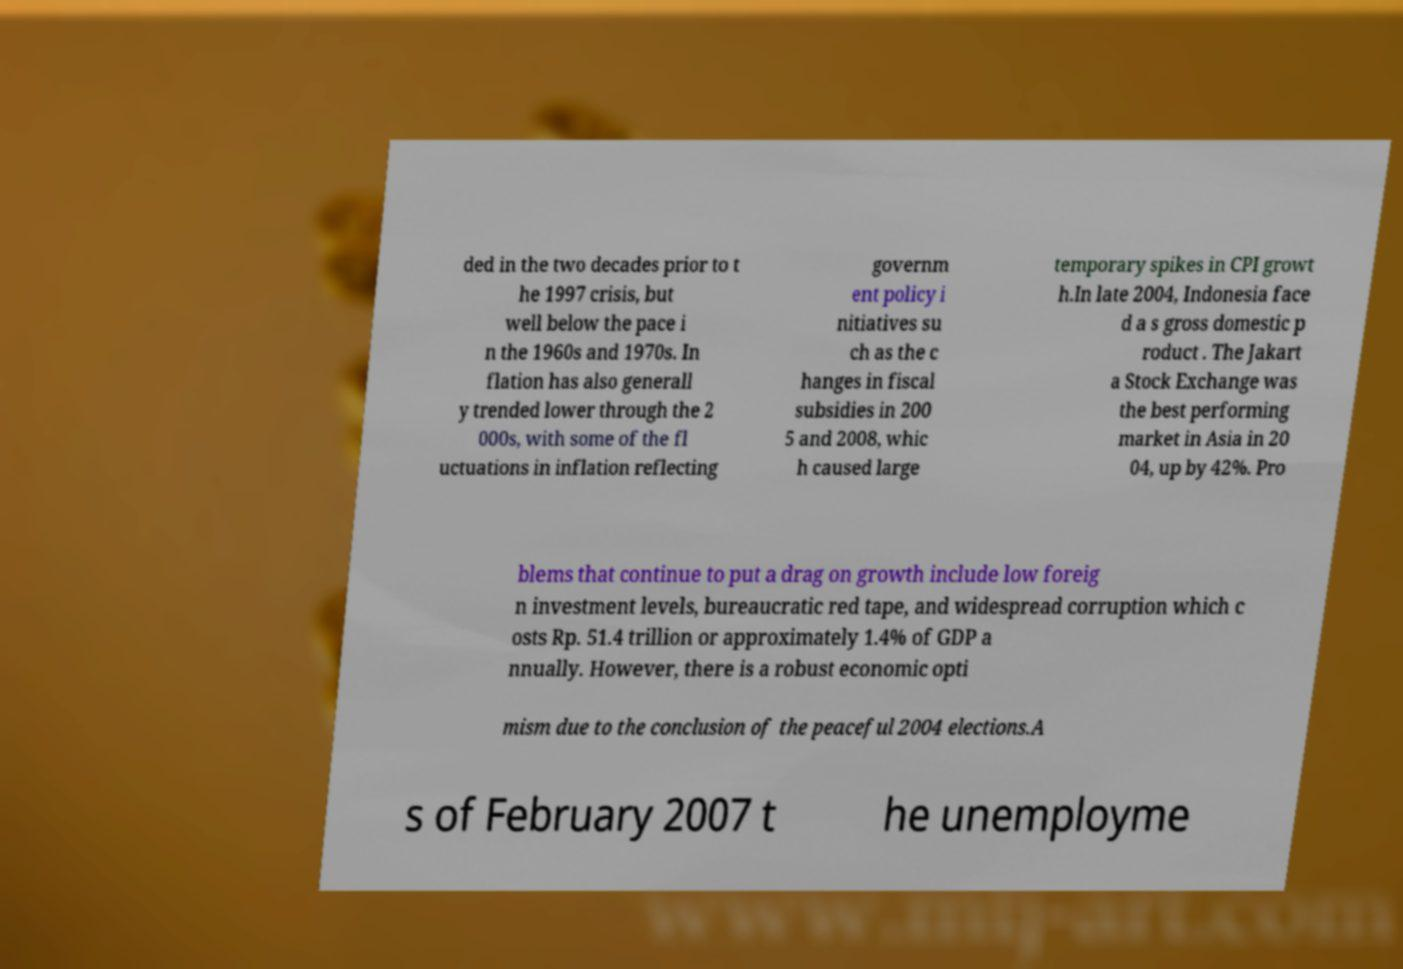I need the written content from this picture converted into text. Can you do that? ded in the two decades prior to t he 1997 crisis, but well below the pace i n the 1960s and 1970s. In flation has also generall y trended lower through the 2 000s, with some of the fl uctuations in inflation reflecting governm ent policy i nitiatives su ch as the c hanges in fiscal subsidies in 200 5 and 2008, whic h caused large temporary spikes in CPI growt h.In late 2004, Indonesia face d a s gross domestic p roduct . The Jakart a Stock Exchange was the best performing market in Asia in 20 04, up by 42%. Pro blems that continue to put a drag on growth include low foreig n investment levels, bureaucratic red tape, and widespread corruption which c osts Rp. 51.4 trillion or approximately 1.4% of GDP a nnually. However, there is a robust economic opti mism due to the conclusion of the peaceful 2004 elections.A s of February 2007 t he unemployme 